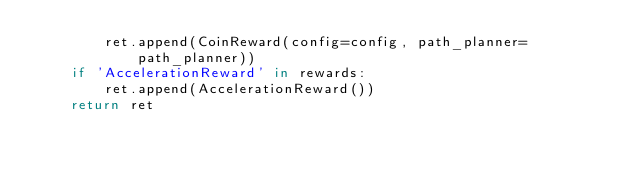<code> <loc_0><loc_0><loc_500><loc_500><_Python_>        ret.append(CoinReward(config=config, path_planner=path_planner))
    if 'AccelerationReward' in rewards:
        ret.append(AccelerationReward())
    return ret
</code> 